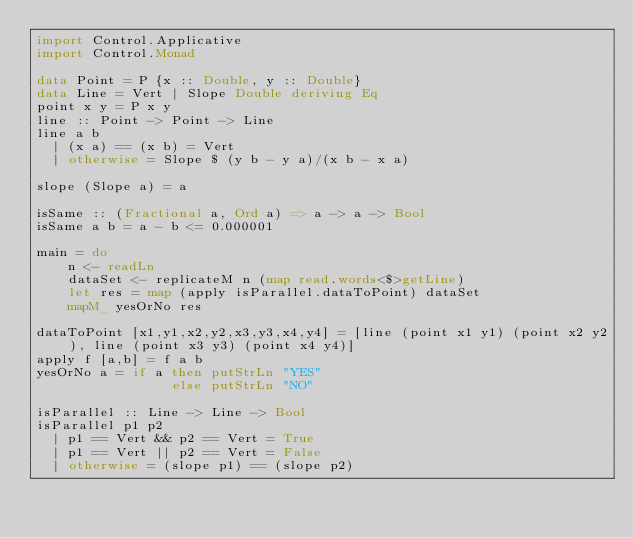Convert code to text. <code><loc_0><loc_0><loc_500><loc_500><_Haskell_>import Control.Applicative
import Control.Monad

data Point = P {x :: Double, y :: Double}
data Line = Vert | Slope Double deriving Eq
point x y = P x y
line :: Point -> Point -> Line
line a b
  | (x a) == (x b) = Vert
  | otherwise = Slope $ (y b - y a)/(x b - x a)

slope (Slope a) = a

isSame :: (Fractional a, Ord a) => a -> a -> Bool
isSame a b = a - b <= 0.000001

main = do
    n <- readLn
    dataSet <- replicateM n (map read.words<$>getLine)
    let res = map (apply isParallel.dataToPoint) dataSet
    mapM_ yesOrNo res

dataToPoint [x1,y1,x2,y2,x3,y3,x4,y4] = [line (point x1 y1) (point x2 y2), line (point x3 y3) (point x4 y4)]
apply f [a,b] = f a b
yesOrNo a = if a then putStrLn "YES"
                 else putStrLn "NO"

isParallel :: Line -> Line -> Bool
isParallel p1 p2
  | p1 == Vert && p2 == Vert = True
  | p1 == Vert || p2 == Vert = False
  | otherwise = (slope p1) == (slope p2)

</code> 